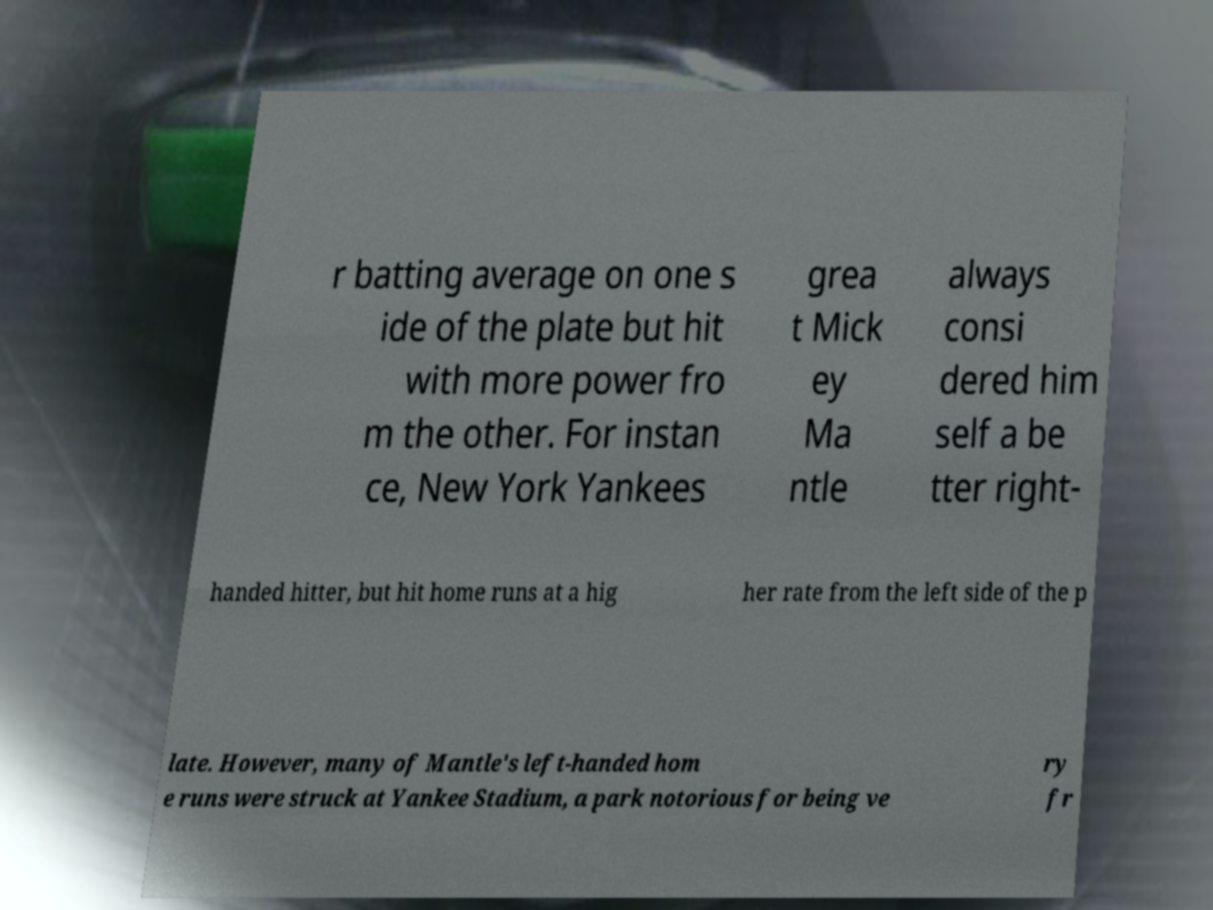Please identify and transcribe the text found in this image. r batting average on one s ide of the plate but hit with more power fro m the other. For instan ce, New York Yankees grea t Mick ey Ma ntle always consi dered him self a be tter right- handed hitter, but hit home runs at a hig her rate from the left side of the p late. However, many of Mantle's left-handed hom e runs were struck at Yankee Stadium, a park notorious for being ve ry fr 